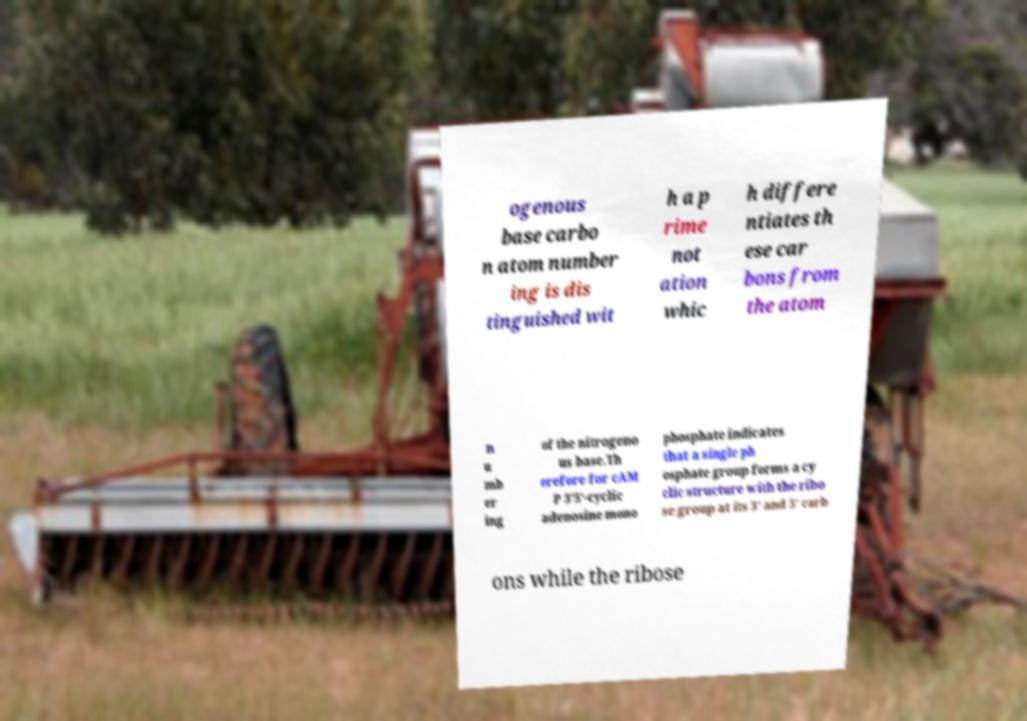What messages or text are displayed in this image? I need them in a readable, typed format. ogenous base carbo n atom number ing is dis tinguished wit h a p rime not ation whic h differe ntiates th ese car bons from the atom n u mb er ing of the nitrogeno us base.Th erefore for cAM P 3’5’-cyclic adenosine mono phosphate indicates that a single ph osphate group forms a cy clic structure with the ribo se group at its 3’ and 5’ carb ons while the ribose 